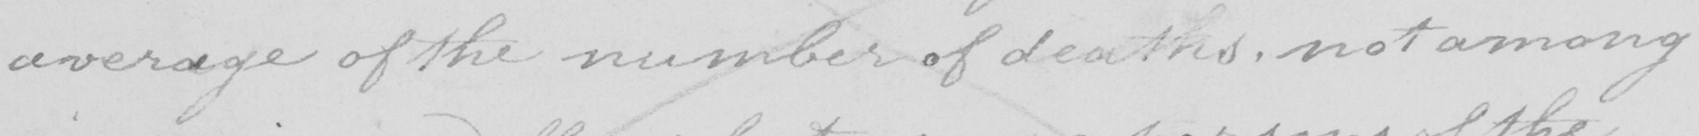Please transcribe the handwritten text in this image. average of the number of deaths , not among 